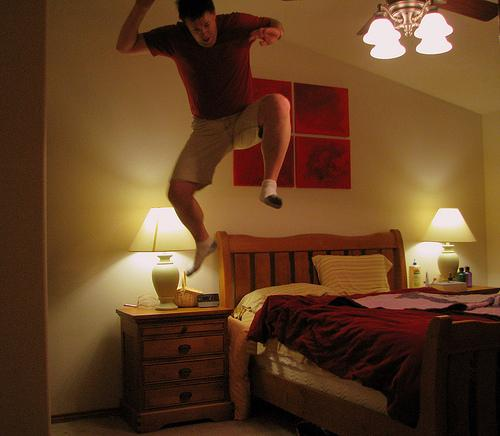In this room, is there any object hanging from the ceiling? Yes, a ceiling fan with lights is hanging from the ceiling. What type of lighting fixtures are used in the room and mention their location? There is a lamp on the nightstand and lights on a ceiling fan, providing lighting in the room. What do the paintings on the wall have in common in terms of their arrangement? All four pictures are hanging close together on the wall, forming a larger decorative element above the bed. How many pillows are on the bed, and what is special about the headboard? There are two pillows on the bed and the headboard is made of wood. Mention a detail about an object located next to the lamp. A basket is sitting next to the lamp on the nightstand. Choose an object in the room and explain its purpose. The lamp on the nightstand is used to provide light in the room and create a cozy atmosphere. Can you identify any storage furniture in the room? There is a nightstand with four drawers beside the bed. Describe the overall condition of the bed, including its main feature. The bed has a rumpled red blanket, a wooden frame, two pillows, and a white mattress. What is the main activity taking place in the image? A man is jumping in the air, wearing a red shirt and white socks. What type of decorative elements are present above the bed? There is a four-part picture on the wall above the bed, with one of them being red. The bedside table has only one drawer. The nightstand in the image has four drawers, so stating that it only has one drawer is incorrect. Is the man wearing a blue shirt while jumping in the air? The man in the image is actually wearing a red shirt, so stating that he is wearing a blue shirt is misleading. Is the ceiling fan in the room turned off? No, it's not mentioned in the image. Can you see a green painting on the wall above the bed? The painting on the wall is described as red, not green, making this instruction misleading. There is no lamp near the bed. There is a lamp on a nightstand near the bed, so stating that there is no lamp is incorrect. Are the man's socks black? The man in the image is wearing white socks, not black, so asking if they are black is misleading and incorrect. The bed has three pillows on it. The bed in the image has two pillows on it, not three, making this statement misleading. Notice the blue blanket on the bed. The blanket on the bed is described as rumpled and red, not blue, so this instruction is incorrect. 